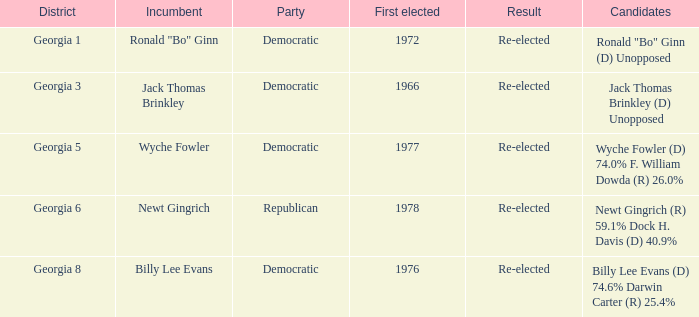Would you mind parsing the complete table? {'header': ['District', 'Incumbent', 'Party', 'First elected', 'Result', 'Candidates'], 'rows': [['Georgia 1', 'Ronald "Bo" Ginn', 'Democratic', '1972', 'Re-elected', 'Ronald "Bo" Ginn (D) Unopposed'], ['Georgia 3', 'Jack Thomas Brinkley', 'Democratic', '1966', 'Re-elected', 'Jack Thomas Brinkley (D) Unopposed'], ['Georgia 5', 'Wyche Fowler', 'Democratic', '1977', 'Re-elected', 'Wyche Fowler (D) 74.0% F. William Dowda (R) 26.0%'], ['Georgia 6', 'Newt Gingrich', 'Republican', '1978', 'Re-elected', 'Newt Gingrich (R) 59.1% Dock H. Davis (D) 40.9%'], ['Georgia 8', 'Billy Lee Evans', 'Democratic', '1976', 'Re-elected', 'Billy Lee Evans (D) 74.6% Darwin Carter (R) 25.4%']]} 9%? Republican. 